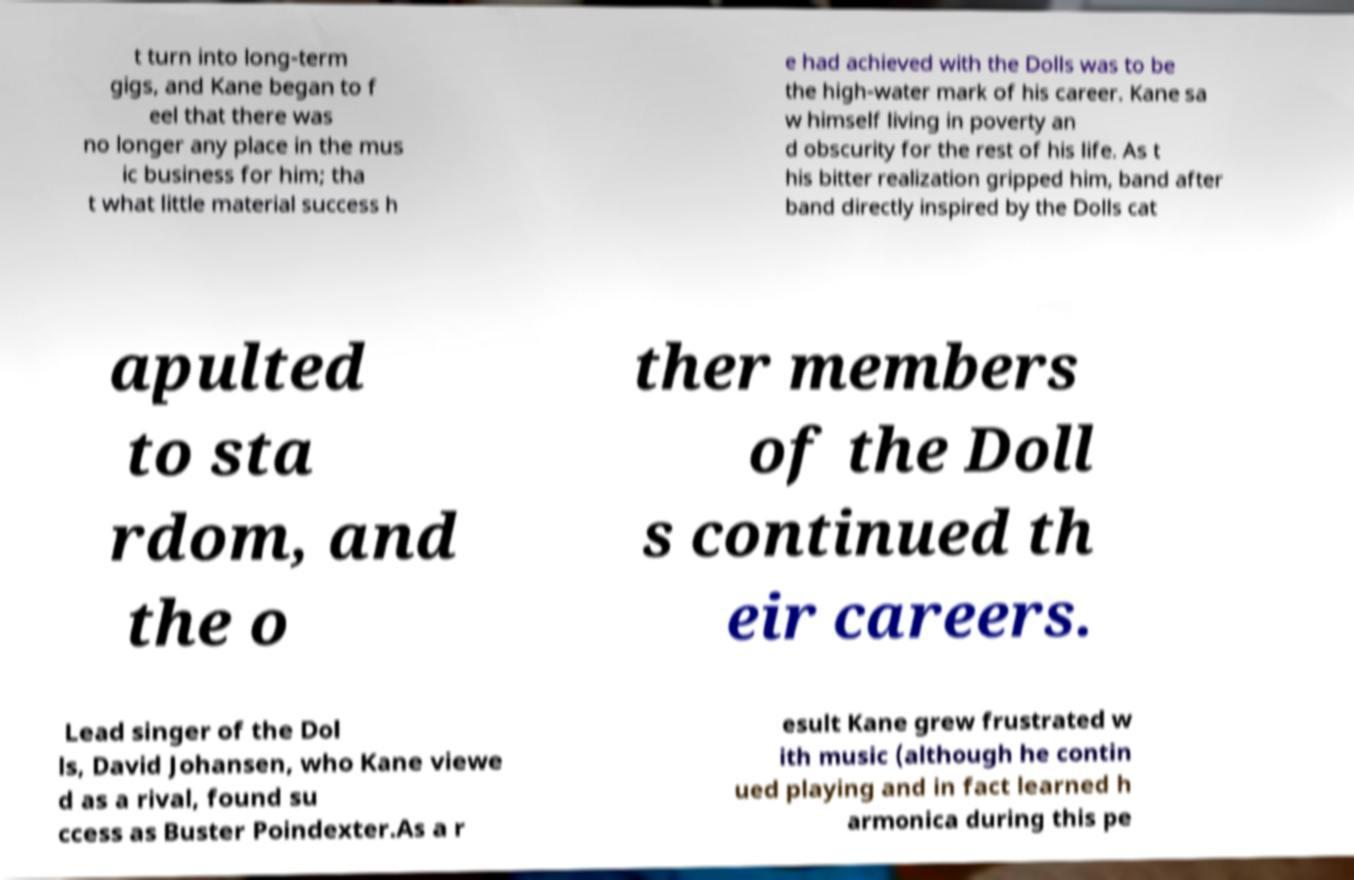Could you assist in decoding the text presented in this image and type it out clearly? t turn into long-term gigs, and Kane began to f eel that there was no longer any place in the mus ic business for him; tha t what little material success h e had achieved with the Dolls was to be the high-water mark of his career. Kane sa w himself living in poverty an d obscurity for the rest of his life. As t his bitter realization gripped him, band after band directly inspired by the Dolls cat apulted to sta rdom, and the o ther members of the Doll s continued th eir careers. Lead singer of the Dol ls, David Johansen, who Kane viewe d as a rival, found su ccess as Buster Poindexter.As a r esult Kane grew frustrated w ith music (although he contin ued playing and in fact learned h armonica during this pe 